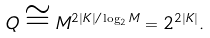Convert formula to latex. <formula><loc_0><loc_0><loc_500><loc_500>Q \cong M ^ { 2 | K | / \log _ { 2 } M } = 2 ^ { 2 | K | } .</formula> 